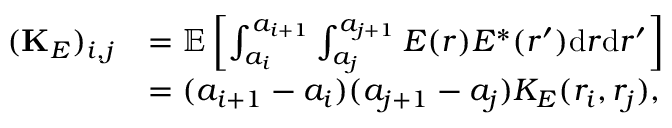Convert formula to latex. <formula><loc_0><loc_0><loc_500><loc_500>\begin{array} { r l } { ( { K } _ { E } ) _ { i , j } } & { = { \mathbb { E } } \left [ \int _ { a _ { i } } ^ { a _ { i + 1 } } \int _ { a _ { j } } ^ { a _ { j + 1 } } E ( r ) E ^ { * } ( r ^ { \prime } ) d r d r ^ { \prime } \right ] } \\ & { = ( a _ { i + 1 } - a _ { i } ) ( a _ { j + 1 } - a _ { j } ) K _ { E } ( r _ { i } , r _ { j } ) , } \end{array}</formula> 